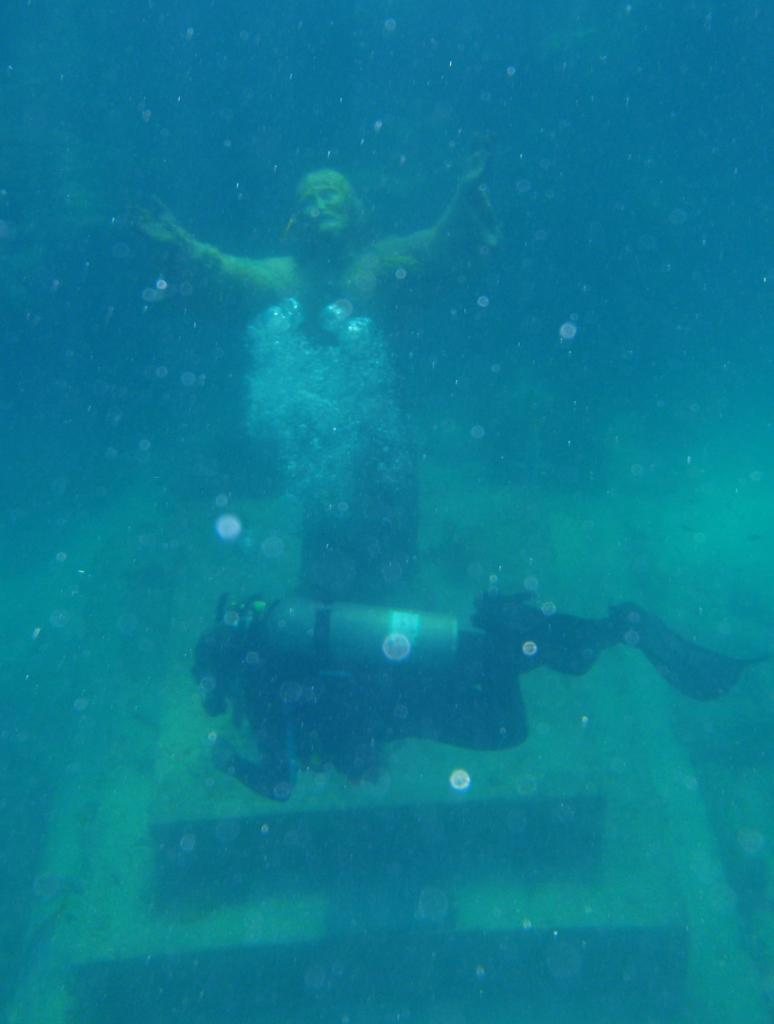Where was the image taken? The image is taken in the water. What can be seen in the center of the image? There is a sculpture in the center of the image. Who or what is in front of the sculpture? A scuba diver is present in front of the sculpture. What type of poisonous substance can be seen near the sculpture in the image? There is no poisonous substance present in the image; it features a scuba diver in front of a sculpture in the water. 